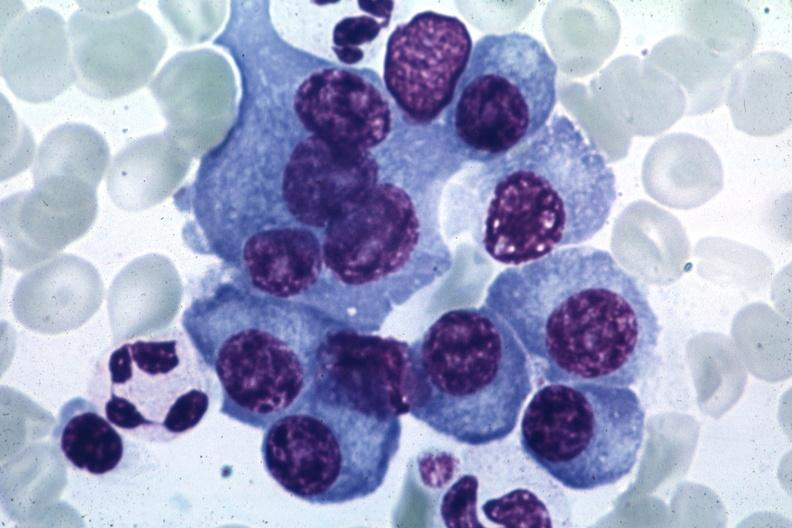how does this image show typical cells?
Answer the question using a single word or phrase. With some pleomorphism suspicious for multiple myeloma source unknown 